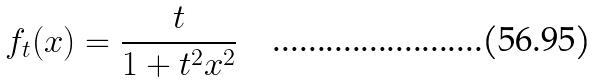<formula> <loc_0><loc_0><loc_500><loc_500>f _ { t } ( x ) = \frac { t } { 1 + t ^ { 2 } x ^ { 2 } }</formula> 